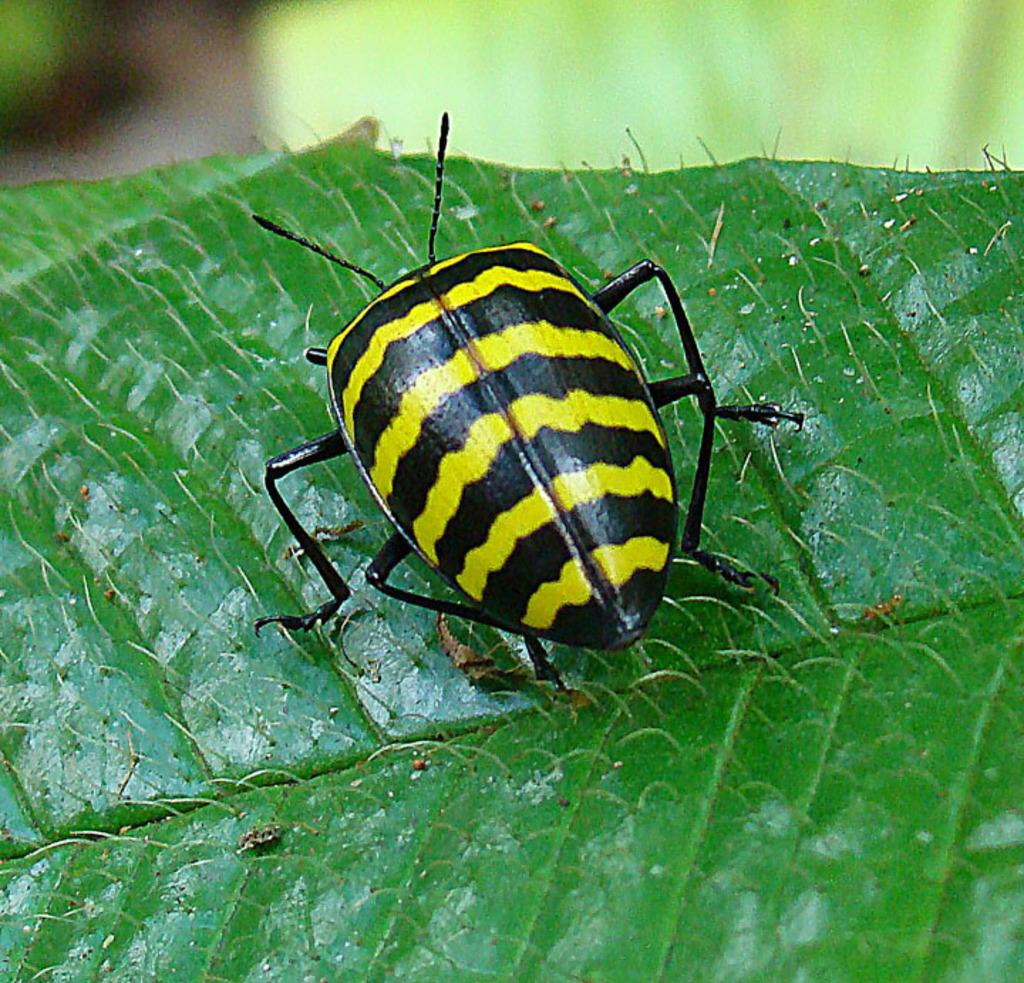What type of plant material is present in the image? There is a green leaf in the image. What is on the leaf in the image? There is a black and yellow insect on the leaf. How would you describe the overall clarity of the image? The image is slightly blurry in the background. Where is the nest of the insect in the image? There is no nest visible in the image; it only shows a black and yellow insect on a green leaf. 